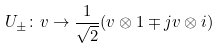<formula> <loc_0><loc_0><loc_500><loc_500>U _ { \pm } \colon v \rightarrow \frac { 1 } { \sqrt { 2 } } ( v \otimes 1 \mp j v \otimes i )</formula> 